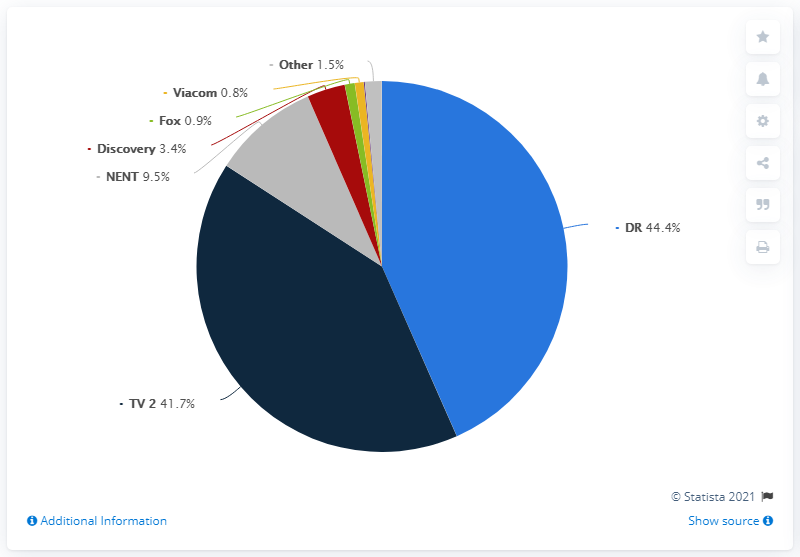Identify some key points in this picture. The sum of the two smallest segments is 1.7. The average and median market shares of the audience of Viacom, Fox, and Discovery are different. Danmark's TV 2 Danmark reached 41.7% of the total viewing time. 